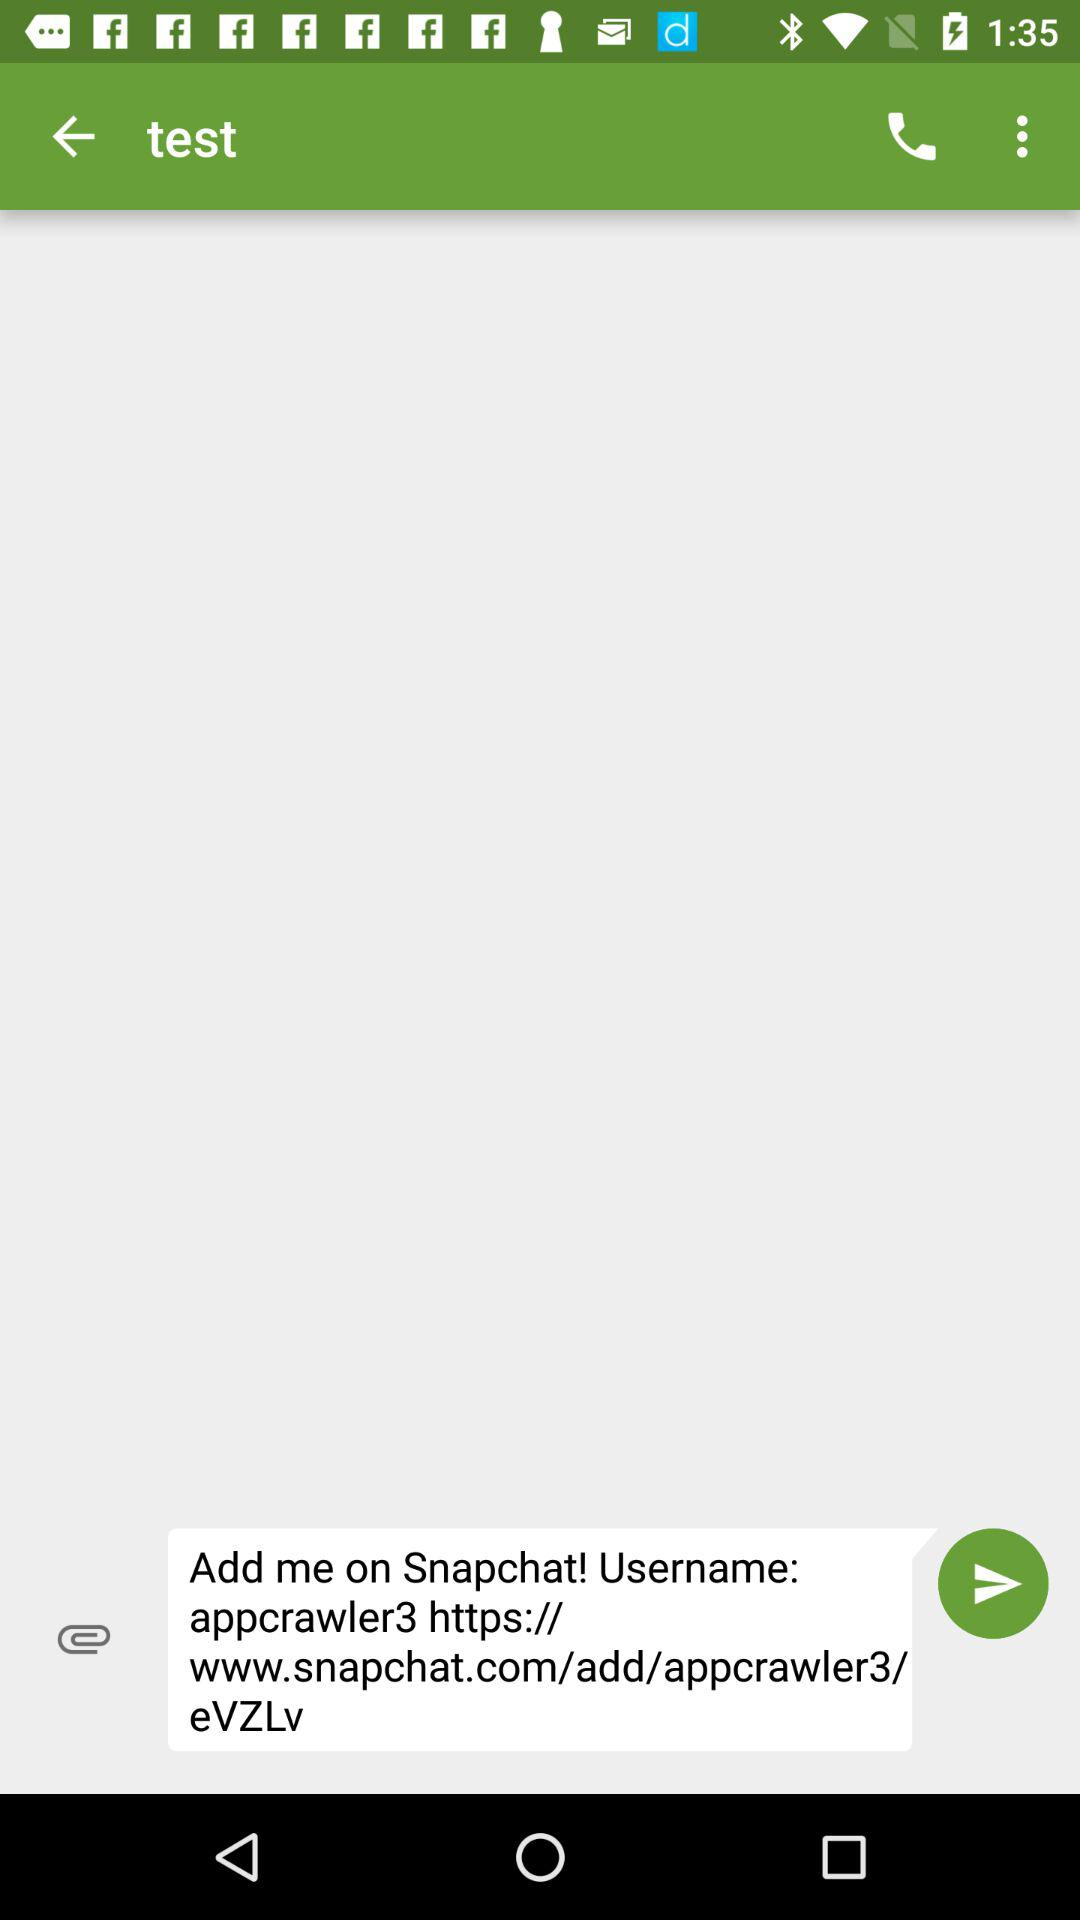What is the username? The username is appcrawler3. 